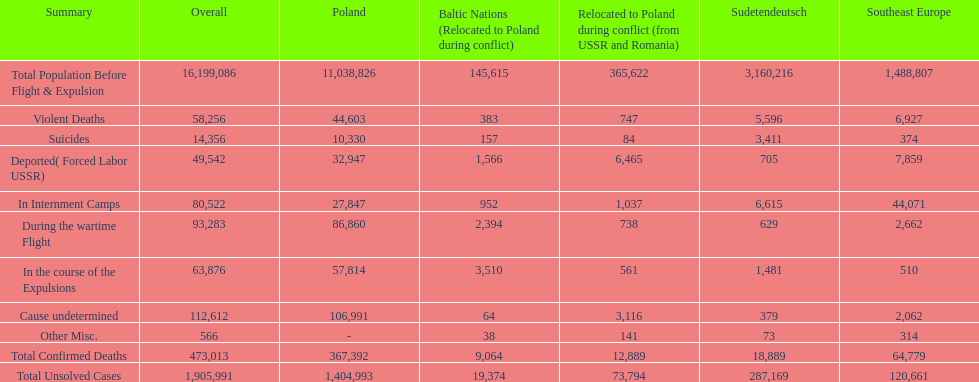How many causes were responsible for more than 50,000 confirmed deaths? 5. 